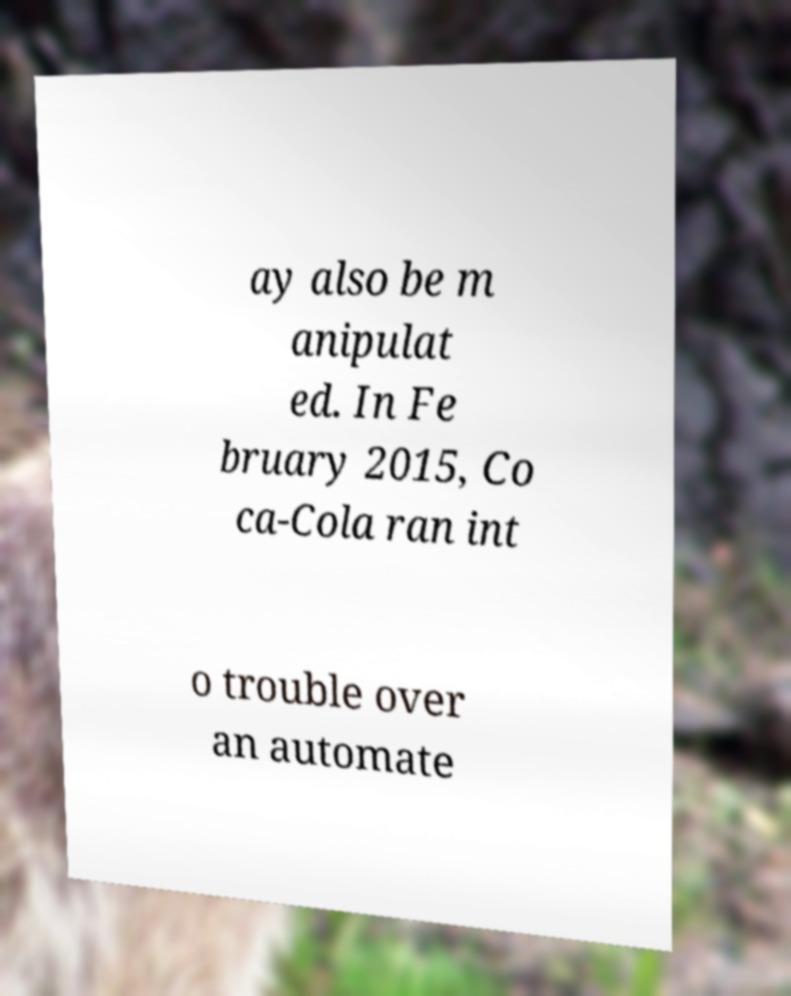Can you read and provide the text displayed in the image?This photo seems to have some interesting text. Can you extract and type it out for me? ay also be m anipulat ed. In Fe bruary 2015, Co ca-Cola ran int o trouble over an automate 